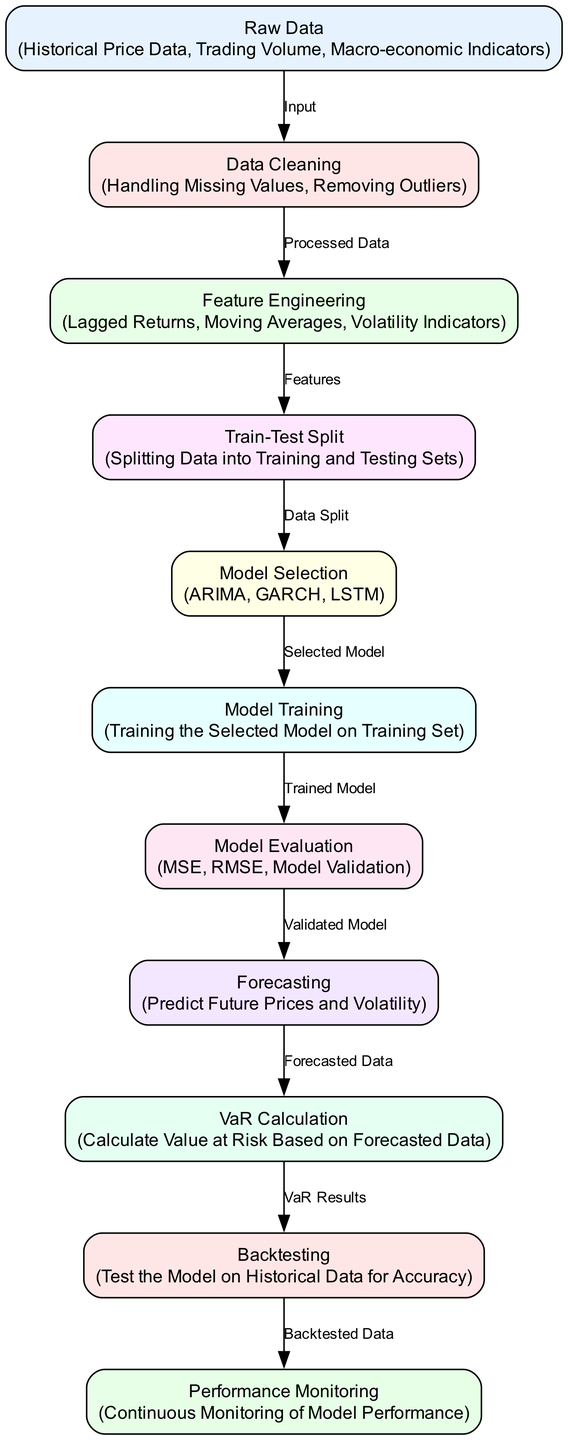What is the starting point of the diagram? The starting point of the diagram is the "Raw Data" node, which represents the initial input for the process.
Answer: Raw Data How many nodes are present in the diagram? To determine the total number of nodes, we count each of the distinct nodes listed. There are ten nodes in total.
Answer: 10 Which model is selected after splitting the data? Following the "Train-Test Split" node, the diagram indicates that the "Model Selection" node determines the model, listed here as ARIMA, GARCH, LSTM.
Answer: Model Selection What is the final output of this diagram? The last node in the flow is "Performance Monitoring," representing the ongoing analysis of model performance after backtesting.
Answer: Performance Monitoring What happens after model evaluation? After "Model Evaluation," the flow proceeds to "Forecasting," which involves predicting future prices and volatility based on the validated model.
Answer: Forecasting How are the outliers handled in the data processing? The "Data Cleaning" node focuses on "Handling Missing Values" and "Removing Outliers," ensuring the dataset is refined before feature engineering.
Answer: Data Cleaning Which node is responsible for calculating Value at Risk? The node designated for the computation of Value at Risk, based on forecasted data, is the "VaR Calculation" node.
Answer: VaR Calculation What is the relationship between forecasting and VaR calculation? The relationship indicates that forecasting provides the necessary data input for the VaR calculation, as demonstrated by the edge labeled "Forecasted Data."
Answer: Forecasted Data What do we assess during backtesting? During "Backtesting," the model is evaluated against historical data to verify its accuracy and effectiveness before deployment.
Answer: Model Accuracy 